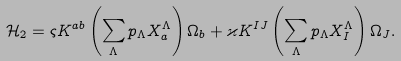Convert formula to latex. <formula><loc_0><loc_0><loc_500><loc_500>\mathcal { H } _ { 2 } = \varsigma K ^ { a b } \left ( \sum _ { \Lambda } p _ { \Lambda } X _ { a } ^ { \Lambda } \right ) \Omega _ { b } + \varkappa K ^ { I J } \left ( \sum _ { \Lambda } p _ { \Lambda } X _ { I } ^ { \Lambda } \right ) \Omega _ { J } .</formula> 